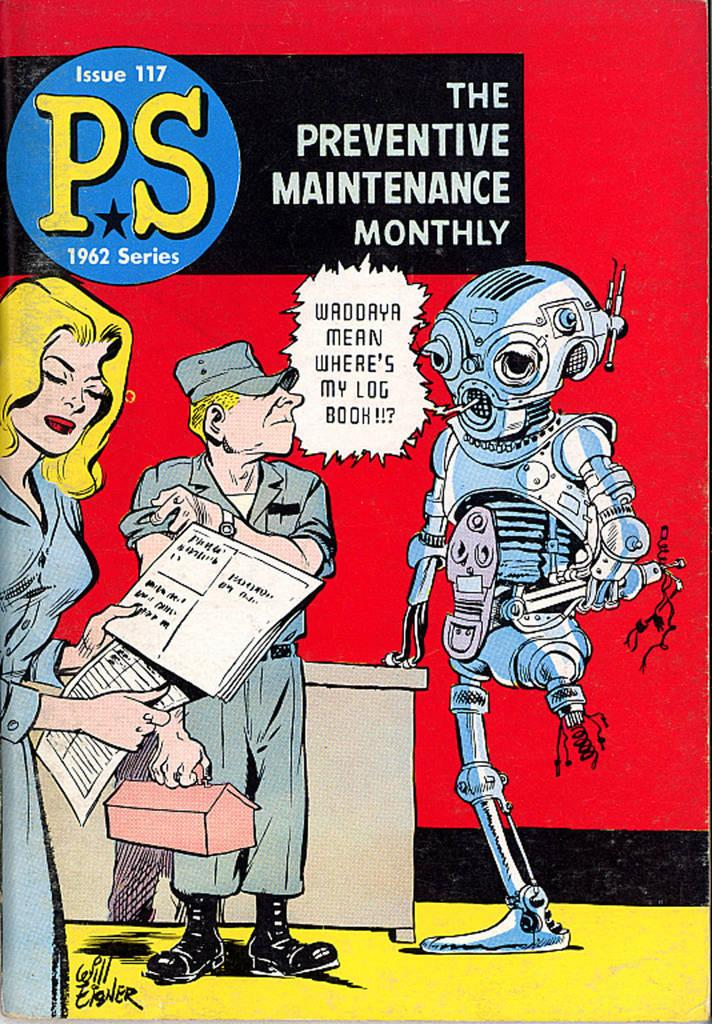What is present in the image that represents a visual display? There is a poster in the image. What type of images are depicted on the poster? The images on the poster resemble a person. Is there any written information on the poster? Yes, there is text on the poster. What type of ornament can be seen hanging from the top of the poster? There is no ornament present on the poster in the image. 